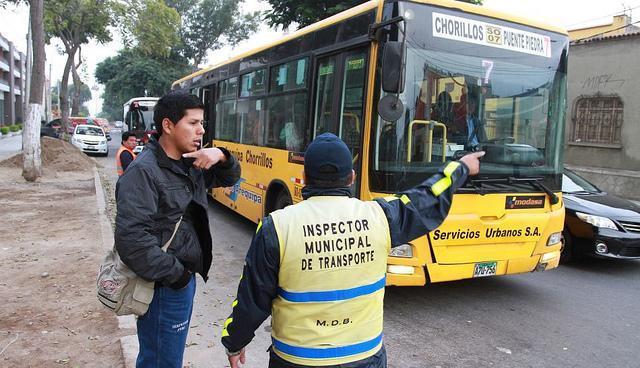How many cars are there?
Give a very brief answer. 1. How many people are there?
Give a very brief answer. 2. 